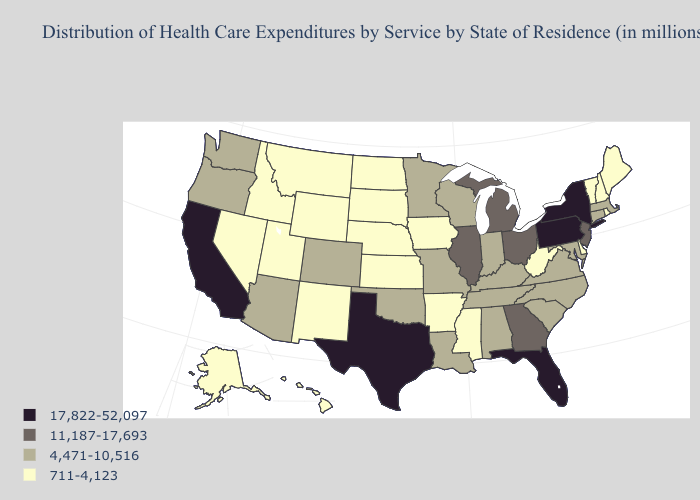Which states hav the highest value in the MidWest?
Answer briefly. Illinois, Michigan, Ohio. Which states hav the highest value in the South?
Answer briefly. Florida, Texas. Does Connecticut have the lowest value in the USA?
Give a very brief answer. No. What is the value of Arizona?
Keep it brief. 4,471-10,516. Does the map have missing data?
Concise answer only. No. Does Idaho have a lower value than South Carolina?
Answer briefly. Yes. What is the highest value in states that border Louisiana?
Keep it brief. 17,822-52,097. Does the first symbol in the legend represent the smallest category?
Keep it brief. No. Does Indiana have a lower value than Florida?
Be succinct. Yes. Does Arizona have a higher value than Alaska?
Keep it brief. Yes. What is the value of Alaska?
Write a very short answer. 711-4,123. What is the value of Arkansas?
Write a very short answer. 711-4,123. What is the highest value in the Northeast ?
Short answer required. 17,822-52,097. What is the value of Hawaii?
Quick response, please. 711-4,123. Name the states that have a value in the range 11,187-17,693?
Keep it brief. Georgia, Illinois, Michigan, New Jersey, Ohio. 